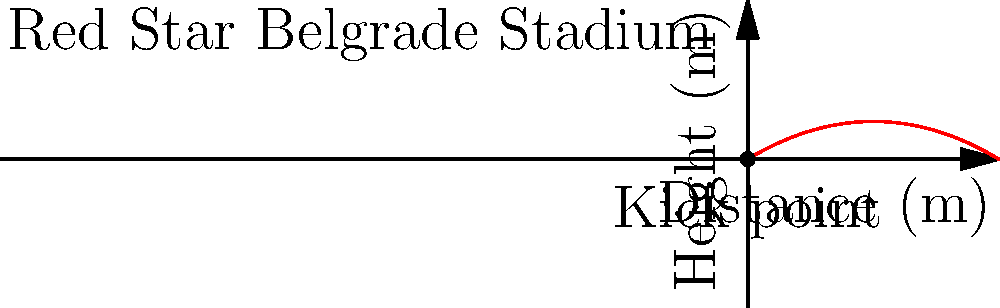A soccer ball is kicked from the Red Star Belgrade stadium, and its trajectory is modeled by the function $h(x) = -0.02x^2 + 0.6x$, where $h$ is the height in meters and $x$ is the horizontal distance in meters. What is the maximum height reached by the ball? To find the maximum height of the ball's trajectory, we need to follow these steps:

1) The function given is $h(x) = -0.02x^2 + 0.6x$, which is a quadratic function (parabola).

2) For a quadratic function in the form $f(x) = ax^2 + bx + c$, the x-coordinate of the vertex is given by $x = -\frac{b}{2a}$.

3) In our case, $a = -0.02$ and $b = 0.6$. Let's substitute these values:

   $x = -\frac{0.6}{2(-0.02)} = -\frac{0.6}{-0.04} = 15$

4) To find the maximum height, we need to calculate $h(15)$:

   $h(15) = -0.02(15)^2 + 0.6(15)$
   $= -0.02(225) + 9$
   $= -4.5 + 9$
   $= 4.5$

Therefore, the maximum height reached by the ball is 4.5 meters.
Answer: 4.5 meters 